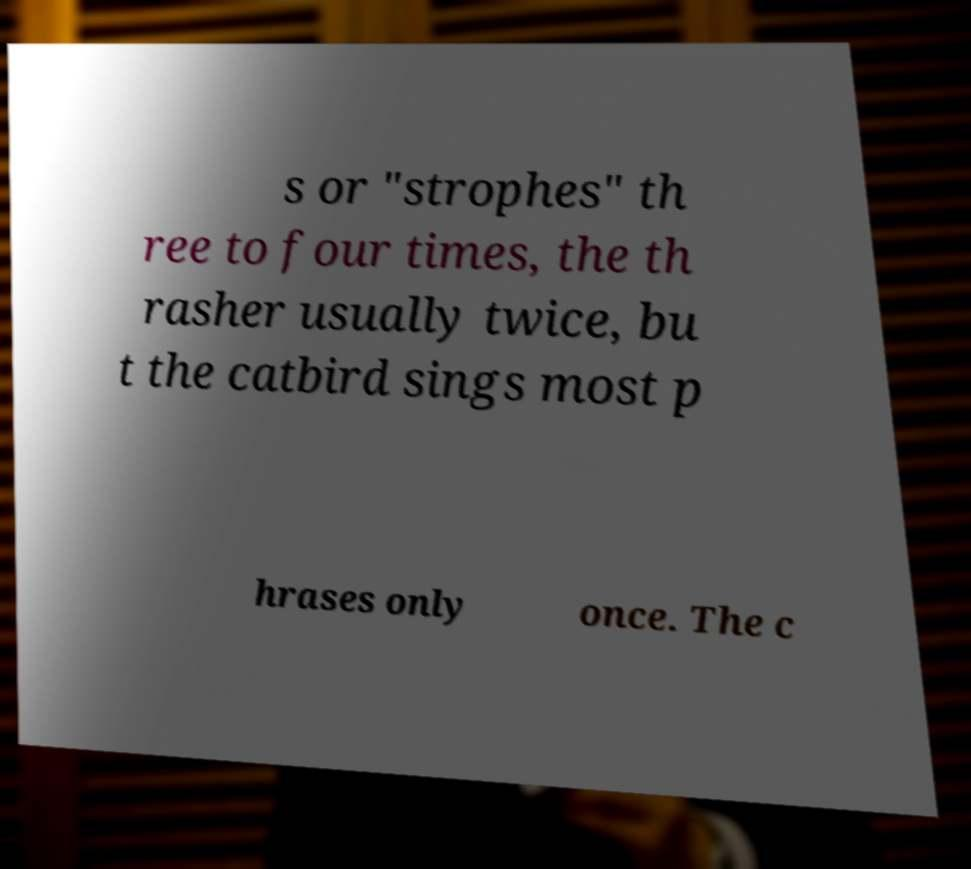Could you extract and type out the text from this image? s or "strophes" th ree to four times, the th rasher usually twice, bu t the catbird sings most p hrases only once. The c 